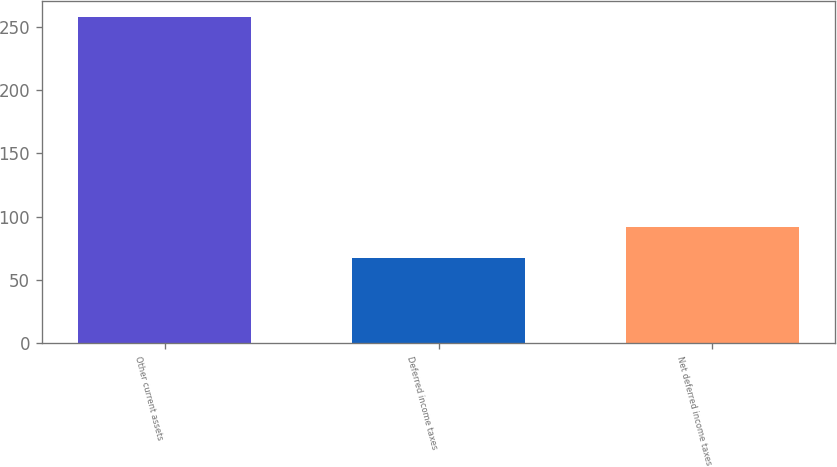Convert chart to OTSL. <chart><loc_0><loc_0><loc_500><loc_500><bar_chart><fcel>Other current assets<fcel>Deferred income taxes<fcel>Net deferred income taxes<nl><fcel>258<fcel>67<fcel>92<nl></chart> 